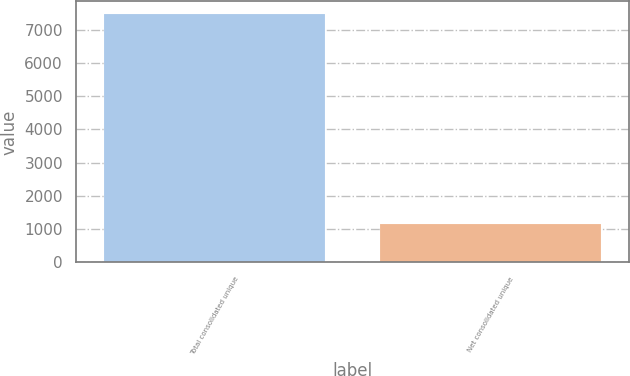<chart> <loc_0><loc_0><loc_500><loc_500><bar_chart><fcel>Total consolidated unique<fcel>Net consolidated unique<nl><fcel>7479<fcel>1163<nl></chart> 